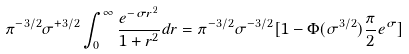Convert formula to latex. <formula><loc_0><loc_0><loc_500><loc_500>\pi ^ { - 3 / 2 } \sigma ^ { + 3 / 2 } \int ^ { \infty } _ { 0 } \frac { e ^ { - \sigma r ^ { 2 } } } { 1 + r ^ { 2 } } d r = \pi ^ { - 3 / 2 } \sigma ^ { - 3 / 2 } [ 1 - \Phi ( \sigma ^ { 3 / 2 } ) \frac { \pi } { 2 } e ^ { \sigma } ]</formula> 